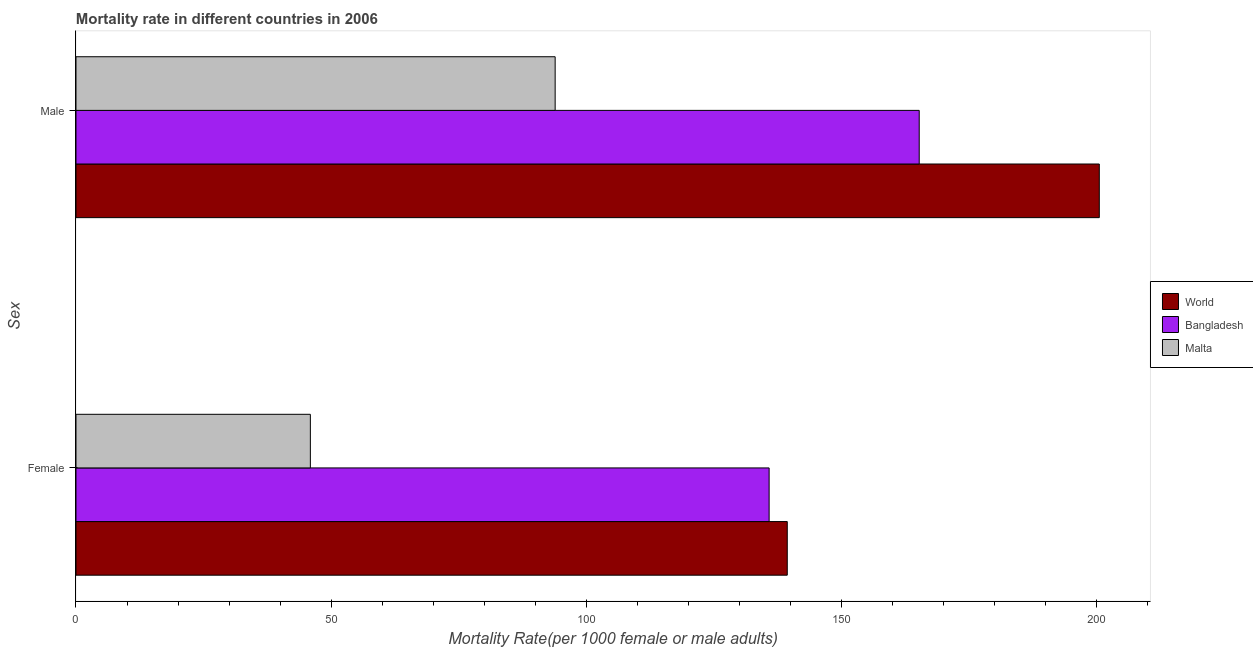How many groups of bars are there?
Ensure brevity in your answer.  2. What is the label of the 2nd group of bars from the top?
Provide a short and direct response. Female. What is the female mortality rate in Malta?
Keep it short and to the point. 45.94. Across all countries, what is the maximum female mortality rate?
Offer a very short reply. 139.41. Across all countries, what is the minimum male mortality rate?
Offer a terse response. 93.92. In which country was the male mortality rate maximum?
Your answer should be very brief. World. In which country was the female mortality rate minimum?
Make the answer very short. Malta. What is the total female mortality rate in the graph?
Offer a terse response. 321.2. What is the difference between the male mortality rate in Malta and that in World?
Provide a succinct answer. -106.65. What is the difference between the male mortality rate in Bangladesh and the female mortality rate in World?
Keep it short and to the point. 25.86. What is the average male mortality rate per country?
Provide a short and direct response. 153.25. What is the difference between the male mortality rate and female mortality rate in Bangladesh?
Offer a very short reply. 29.42. What is the ratio of the male mortality rate in World to that in Malta?
Your answer should be compact. 2.14. In how many countries, is the male mortality rate greater than the average male mortality rate taken over all countries?
Offer a very short reply. 2. How many bars are there?
Give a very brief answer. 6. Are the values on the major ticks of X-axis written in scientific E-notation?
Your response must be concise. No. Does the graph contain grids?
Offer a very short reply. No. Where does the legend appear in the graph?
Provide a short and direct response. Center right. How many legend labels are there?
Ensure brevity in your answer.  3. What is the title of the graph?
Your response must be concise. Mortality rate in different countries in 2006. What is the label or title of the X-axis?
Make the answer very short. Mortality Rate(per 1000 female or male adults). What is the label or title of the Y-axis?
Your answer should be very brief. Sex. What is the Mortality Rate(per 1000 female or male adults) of World in Female?
Provide a succinct answer. 139.41. What is the Mortality Rate(per 1000 female or male adults) in Bangladesh in Female?
Make the answer very short. 135.86. What is the Mortality Rate(per 1000 female or male adults) in Malta in Female?
Keep it short and to the point. 45.94. What is the Mortality Rate(per 1000 female or male adults) of World in Male?
Your response must be concise. 200.57. What is the Mortality Rate(per 1000 female or male adults) in Bangladesh in Male?
Provide a short and direct response. 165.27. What is the Mortality Rate(per 1000 female or male adults) of Malta in Male?
Make the answer very short. 93.92. Across all Sex, what is the maximum Mortality Rate(per 1000 female or male adults) of World?
Keep it short and to the point. 200.57. Across all Sex, what is the maximum Mortality Rate(per 1000 female or male adults) of Bangladesh?
Ensure brevity in your answer.  165.27. Across all Sex, what is the maximum Mortality Rate(per 1000 female or male adults) of Malta?
Provide a succinct answer. 93.92. Across all Sex, what is the minimum Mortality Rate(per 1000 female or male adults) in World?
Provide a succinct answer. 139.41. Across all Sex, what is the minimum Mortality Rate(per 1000 female or male adults) of Bangladesh?
Keep it short and to the point. 135.86. Across all Sex, what is the minimum Mortality Rate(per 1000 female or male adults) in Malta?
Your answer should be compact. 45.94. What is the total Mortality Rate(per 1000 female or male adults) in World in the graph?
Provide a succinct answer. 339.98. What is the total Mortality Rate(per 1000 female or male adults) of Bangladesh in the graph?
Ensure brevity in your answer.  301.13. What is the total Mortality Rate(per 1000 female or male adults) in Malta in the graph?
Make the answer very short. 139.85. What is the difference between the Mortality Rate(per 1000 female or male adults) of World in Female and that in Male?
Provide a short and direct response. -61.16. What is the difference between the Mortality Rate(per 1000 female or male adults) in Bangladesh in Female and that in Male?
Keep it short and to the point. -29.42. What is the difference between the Mortality Rate(per 1000 female or male adults) in Malta in Female and that in Male?
Keep it short and to the point. -47.98. What is the difference between the Mortality Rate(per 1000 female or male adults) of World in Female and the Mortality Rate(per 1000 female or male adults) of Bangladesh in Male?
Provide a short and direct response. -25.86. What is the difference between the Mortality Rate(per 1000 female or male adults) in World in Female and the Mortality Rate(per 1000 female or male adults) in Malta in Male?
Offer a terse response. 45.49. What is the difference between the Mortality Rate(per 1000 female or male adults) of Bangladesh in Female and the Mortality Rate(per 1000 female or male adults) of Malta in Male?
Make the answer very short. 41.94. What is the average Mortality Rate(per 1000 female or male adults) in World per Sex?
Make the answer very short. 169.99. What is the average Mortality Rate(per 1000 female or male adults) in Bangladesh per Sex?
Make the answer very short. 150.56. What is the average Mortality Rate(per 1000 female or male adults) in Malta per Sex?
Give a very brief answer. 69.93. What is the difference between the Mortality Rate(per 1000 female or male adults) in World and Mortality Rate(per 1000 female or male adults) in Bangladesh in Female?
Offer a terse response. 3.55. What is the difference between the Mortality Rate(per 1000 female or male adults) in World and Mortality Rate(per 1000 female or male adults) in Malta in Female?
Provide a succinct answer. 93.47. What is the difference between the Mortality Rate(per 1000 female or male adults) of Bangladesh and Mortality Rate(per 1000 female or male adults) of Malta in Female?
Keep it short and to the point. 89.92. What is the difference between the Mortality Rate(per 1000 female or male adults) of World and Mortality Rate(per 1000 female or male adults) of Bangladesh in Male?
Ensure brevity in your answer.  35.29. What is the difference between the Mortality Rate(per 1000 female or male adults) in World and Mortality Rate(per 1000 female or male adults) in Malta in Male?
Offer a terse response. 106.65. What is the difference between the Mortality Rate(per 1000 female or male adults) of Bangladesh and Mortality Rate(per 1000 female or male adults) of Malta in Male?
Give a very brief answer. 71.36. What is the ratio of the Mortality Rate(per 1000 female or male adults) in World in Female to that in Male?
Your answer should be very brief. 0.7. What is the ratio of the Mortality Rate(per 1000 female or male adults) of Bangladesh in Female to that in Male?
Your response must be concise. 0.82. What is the ratio of the Mortality Rate(per 1000 female or male adults) in Malta in Female to that in Male?
Offer a very short reply. 0.49. What is the difference between the highest and the second highest Mortality Rate(per 1000 female or male adults) in World?
Your response must be concise. 61.16. What is the difference between the highest and the second highest Mortality Rate(per 1000 female or male adults) of Bangladesh?
Offer a terse response. 29.42. What is the difference between the highest and the second highest Mortality Rate(per 1000 female or male adults) of Malta?
Give a very brief answer. 47.98. What is the difference between the highest and the lowest Mortality Rate(per 1000 female or male adults) of World?
Provide a succinct answer. 61.16. What is the difference between the highest and the lowest Mortality Rate(per 1000 female or male adults) in Bangladesh?
Provide a short and direct response. 29.42. What is the difference between the highest and the lowest Mortality Rate(per 1000 female or male adults) in Malta?
Your answer should be compact. 47.98. 